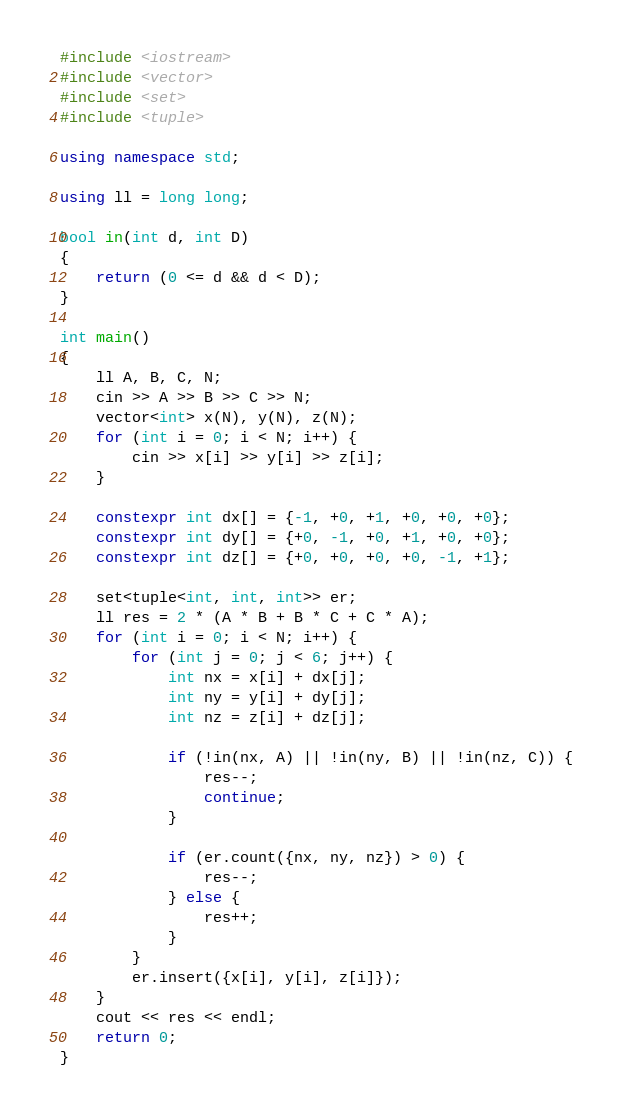<code> <loc_0><loc_0><loc_500><loc_500><_C++_>#include <iostream>
#include <vector>
#include <set>
#include <tuple>

using namespace std;

using ll = long long;

bool in(int d, int D)
{
    return (0 <= d && d < D);
}

int main()
{
    ll A, B, C, N;
    cin >> A >> B >> C >> N;
    vector<int> x(N), y(N), z(N);
    for (int i = 0; i < N; i++) {
        cin >> x[i] >> y[i] >> z[i];
    }
    
    constexpr int dx[] = {-1, +0, +1, +0, +0, +0};
    constexpr int dy[] = {+0, -1, +0, +1, +0, +0};
    constexpr int dz[] = {+0, +0, +0, +0, -1, +1};
    
    set<tuple<int, int, int>> er;
    ll res = 2 * (A * B + B * C + C * A);
    for (int i = 0; i < N; i++) {
        for (int j = 0; j < 6; j++) {
            int nx = x[i] + dx[j];
            int ny = y[i] + dy[j];
            int nz = z[i] + dz[j];

            if (!in(nx, A) || !in(ny, B) || !in(nz, C)) {
                res--;
                continue;
            }

            if (er.count({nx, ny, nz}) > 0) {
                res--;
            } else {
                res++;
            }            
        }
        er.insert({x[i], y[i], z[i]});
    }
    cout << res << endl;
    return 0;
}</code> 